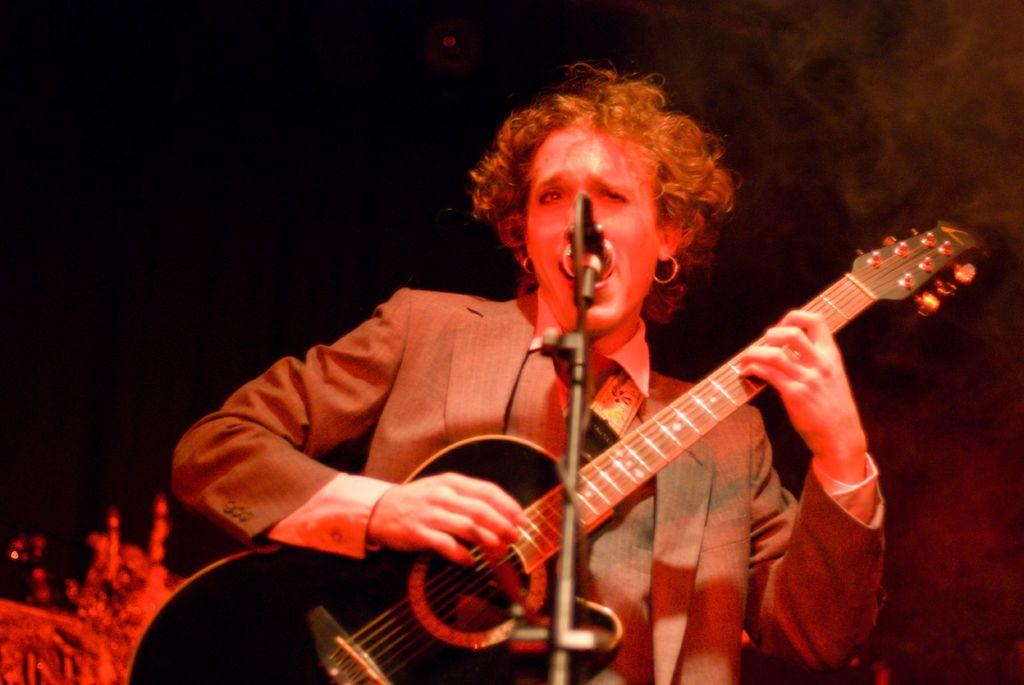What is the main subject of the image? There is a person in the image. What is the person holding in the image? The person is holding a guitar. What is the person doing with the guitar? The person is playing the guitar. What can be seen in front of the person? The person is standing in front of a microphone. How would you describe the lighting in the image? The background of the image is dark. Can you see any fangs on the person playing the guitar in the image? There are no fangs visible on the person playing the guitar in the image. What type of account is being discussed in the image? There is no mention of an account in the image; it features a person playing a guitar in front of a microphone. 